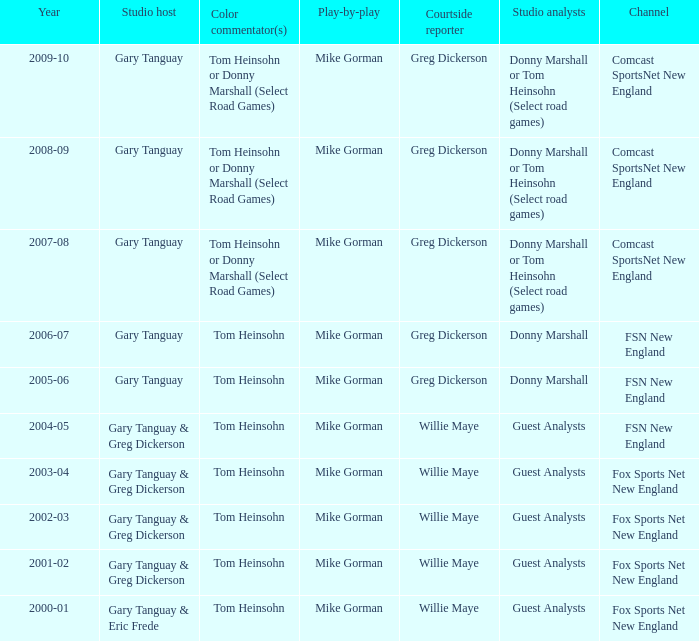WHich Studio host has a Year of 2003-04? Gary Tanguay & Greg Dickerson. 